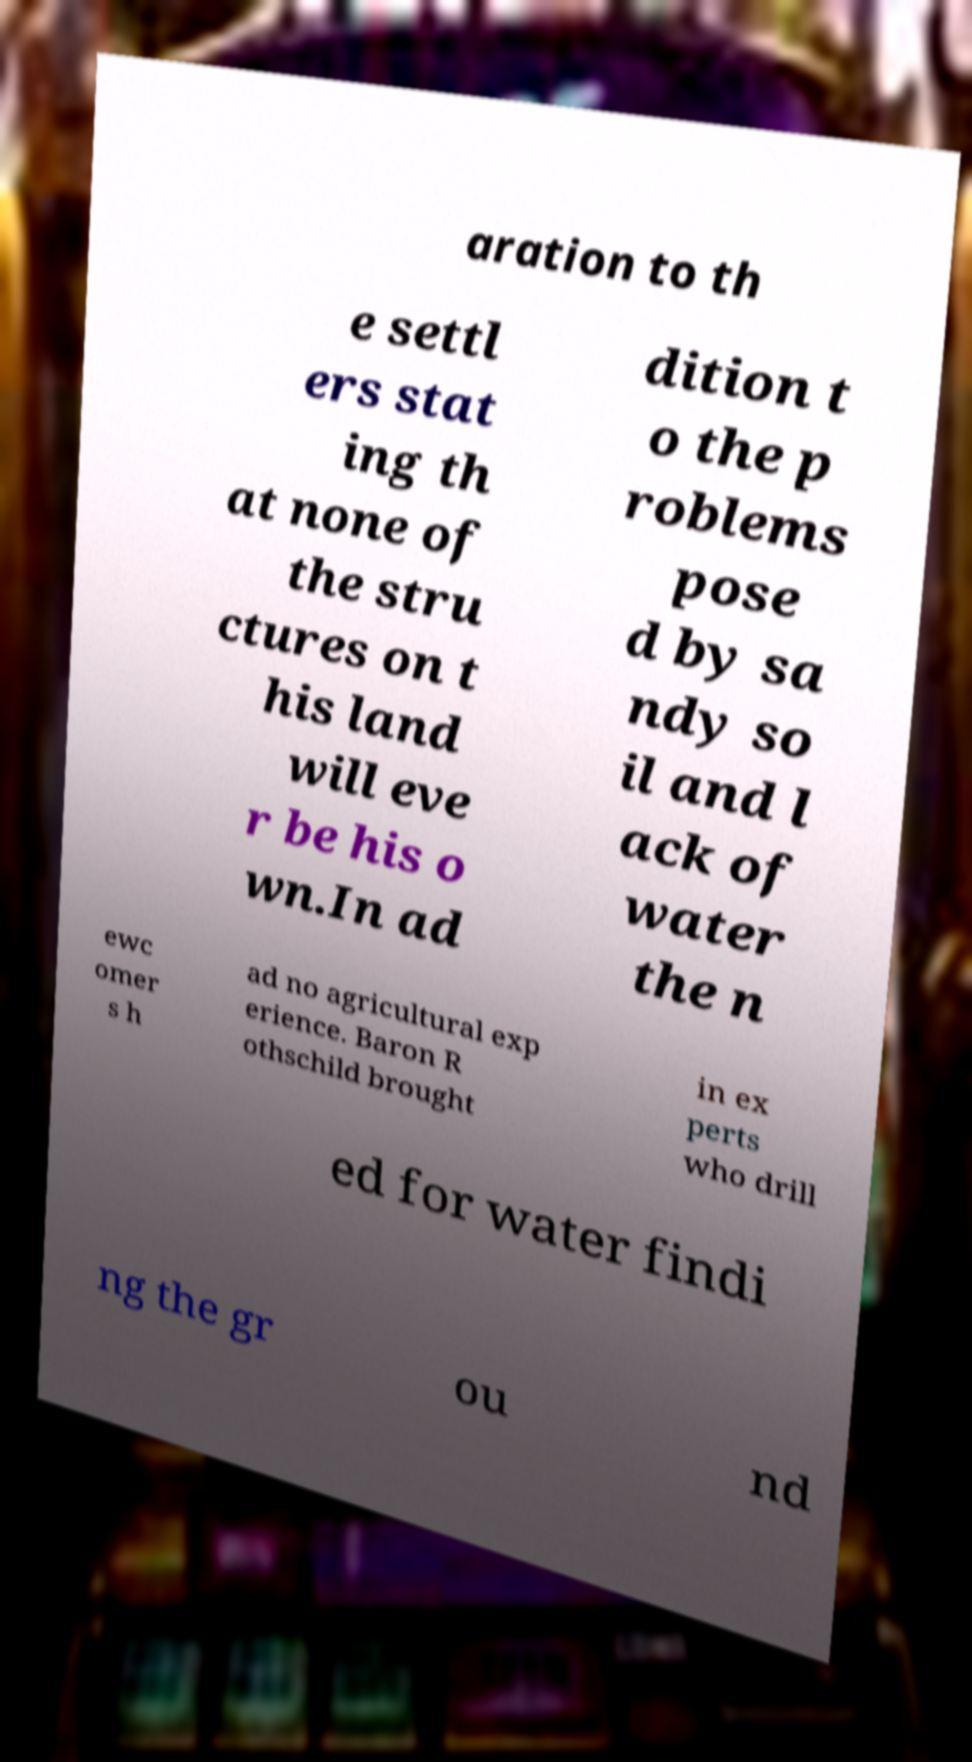Could you extract and type out the text from this image? aration to th e settl ers stat ing th at none of the stru ctures on t his land will eve r be his o wn.In ad dition t o the p roblems pose d by sa ndy so il and l ack of water the n ewc omer s h ad no agricultural exp erience. Baron R othschild brought in ex perts who drill ed for water findi ng the gr ou nd 